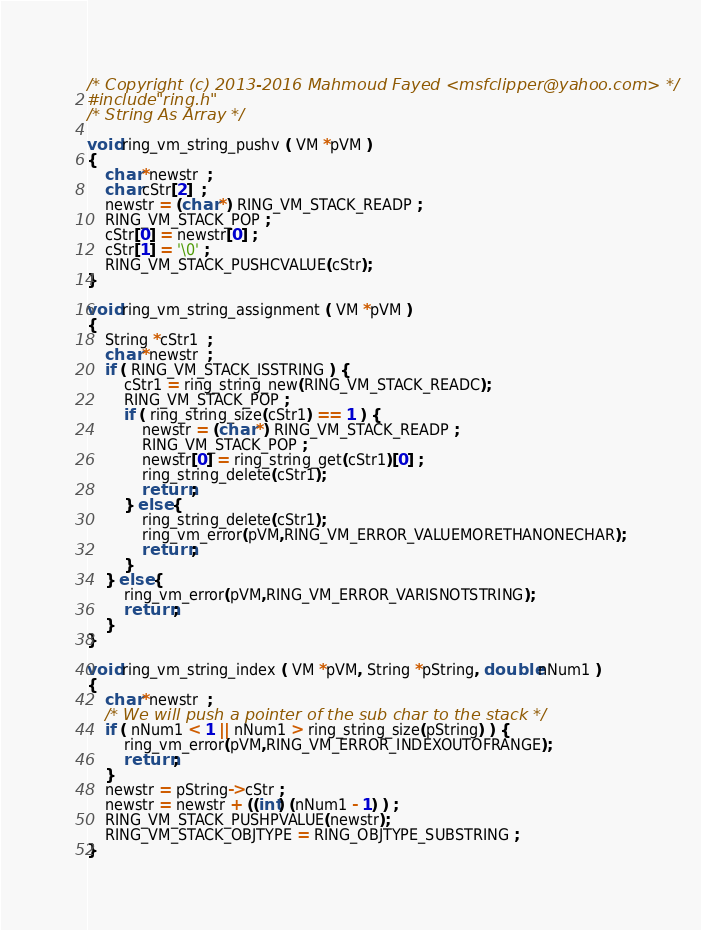Convert code to text. <code><loc_0><loc_0><loc_500><loc_500><_C_>/* Copyright (c) 2013-2016 Mahmoud Fayed <msfclipper@yahoo.com> */
#include "ring.h"
/* String As Array */

void ring_vm_string_pushv ( VM *pVM )
{
	char *newstr  ;
	char cStr[2]  ;
	newstr = (char *) RING_VM_STACK_READP ;
	RING_VM_STACK_POP ;
	cStr[0] = newstr[0] ;
	cStr[1] = '\0' ;
	RING_VM_STACK_PUSHCVALUE(cStr);
}

void ring_vm_string_assignment ( VM *pVM )
{
	String *cStr1  ;
	char *newstr  ;
	if ( RING_VM_STACK_ISSTRING ) {
		cStr1 = ring_string_new(RING_VM_STACK_READC);
		RING_VM_STACK_POP ;
		if ( ring_string_size(cStr1) == 1 ) {
			newstr = (char *) RING_VM_STACK_READP ;
			RING_VM_STACK_POP ;
			newstr[0] = ring_string_get(cStr1)[0] ;
			ring_string_delete(cStr1);
			return ;
		} else {
			ring_string_delete(cStr1);
			ring_vm_error(pVM,RING_VM_ERROR_VALUEMORETHANONECHAR);
			return ;
		}
	} else {
		ring_vm_error(pVM,RING_VM_ERROR_VARISNOTSTRING);
		return ;
	}
}

void ring_vm_string_index ( VM *pVM, String *pString, double nNum1 )
{
	char *newstr  ;
	/* We will push a pointer of the sub char to the stack */
	if ( nNum1 < 1 || nNum1 > ring_string_size(pString) ) {
		ring_vm_error(pVM,RING_VM_ERROR_INDEXOUTOFRANGE);
		return ;
	}
	newstr = pString->cStr ;
	newstr = newstr + ((int) (nNum1 - 1) ) ;
	RING_VM_STACK_PUSHPVALUE(newstr);
	RING_VM_STACK_OBJTYPE = RING_OBJTYPE_SUBSTRING ;
}
</code> 